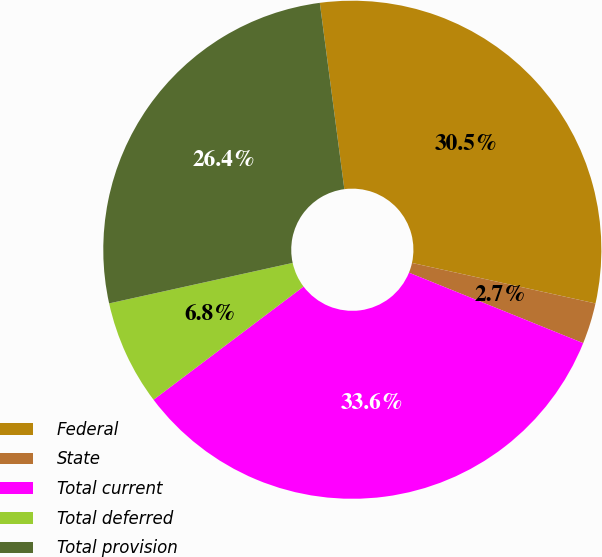Convert chart to OTSL. <chart><loc_0><loc_0><loc_500><loc_500><pie_chart><fcel>Federal<fcel>State<fcel>Total current<fcel>Total deferred<fcel>Total provision<nl><fcel>30.54%<fcel>2.66%<fcel>33.59%<fcel>6.83%<fcel>26.37%<nl></chart> 